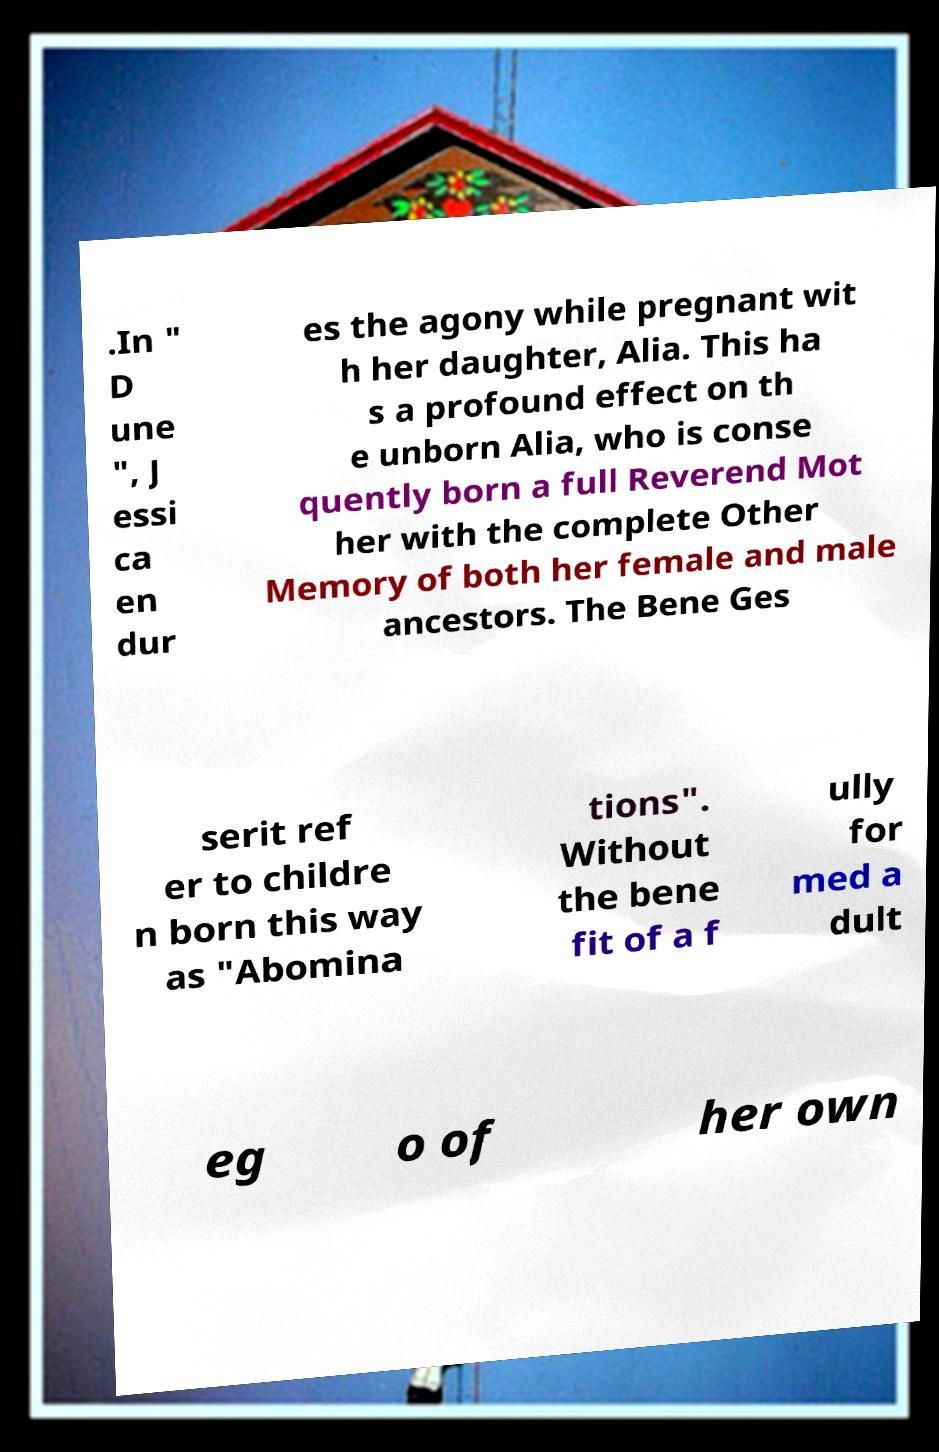There's text embedded in this image that I need extracted. Can you transcribe it verbatim? .In " D une ", J essi ca en dur es the agony while pregnant wit h her daughter, Alia. This ha s a profound effect on th e unborn Alia, who is conse quently born a full Reverend Mot her with the complete Other Memory of both her female and male ancestors. The Bene Ges serit ref er to childre n born this way as "Abomina tions". Without the bene fit of a f ully for med a dult eg o of her own 